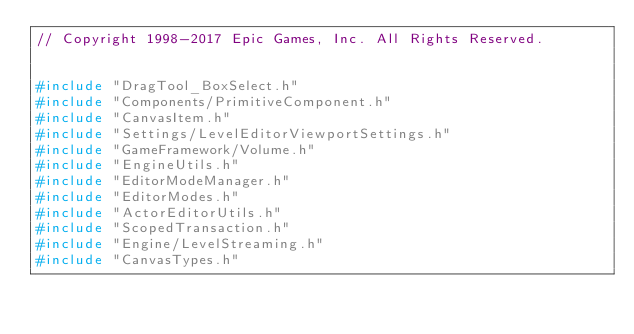Convert code to text. <code><loc_0><loc_0><loc_500><loc_500><_C++_>// Copyright 1998-2017 Epic Games, Inc. All Rights Reserved.


#include "DragTool_BoxSelect.h"
#include "Components/PrimitiveComponent.h"
#include "CanvasItem.h"
#include "Settings/LevelEditorViewportSettings.h"
#include "GameFramework/Volume.h"
#include "EngineUtils.h"
#include "EditorModeManager.h"
#include "EditorModes.h"
#include "ActorEditorUtils.h"
#include "ScopedTransaction.h"
#include "Engine/LevelStreaming.h"
#include "CanvasTypes.h"
</code> 